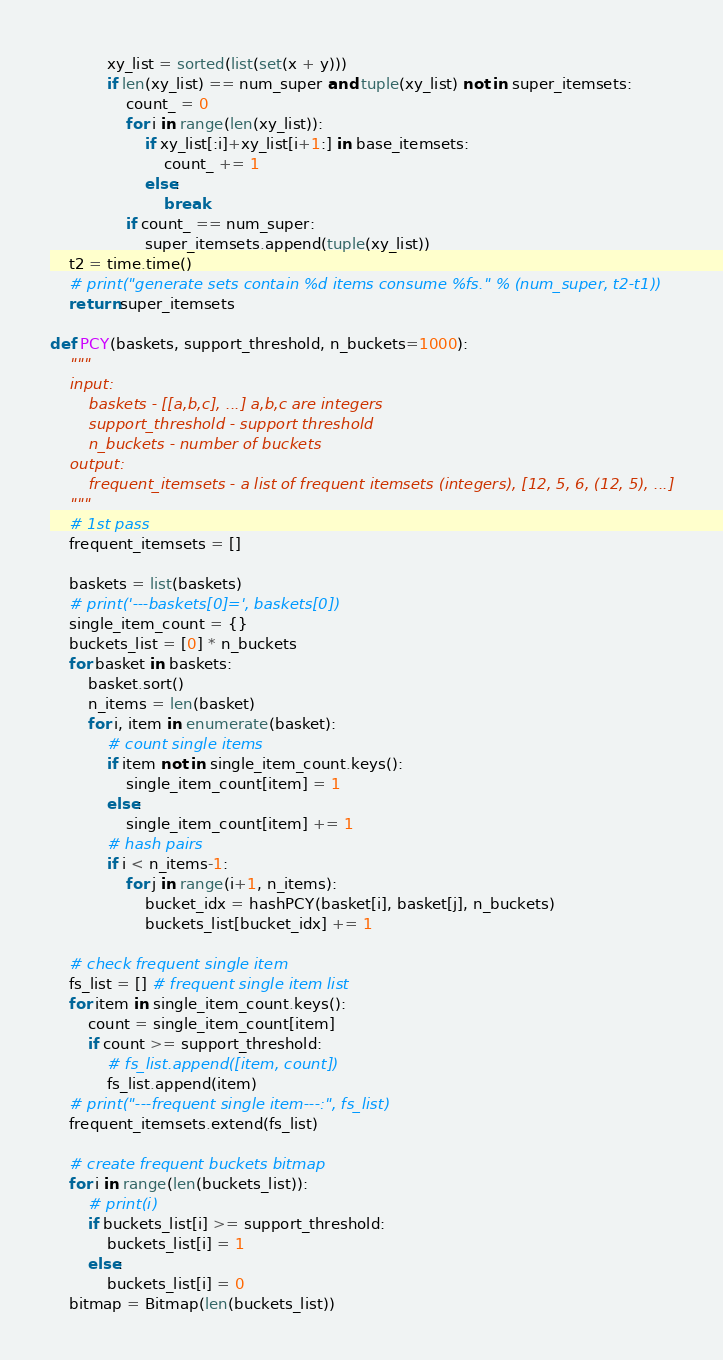<code> <loc_0><loc_0><loc_500><loc_500><_Python_>            xy_list = sorted(list(set(x + y)))
            if len(xy_list) == num_super and tuple(xy_list) not in super_itemsets:
                count_ = 0
                for i in range(len(xy_list)):
                    if xy_list[:i]+xy_list[i+1:] in base_itemsets:
                        count_ += 1
                    else:
                        break
                if count_ == num_super:
                    super_itemsets.append(tuple(xy_list))
    t2 = time.time()
    # print("generate sets contain %d items consume %fs." % (num_super, t2-t1))
    return super_itemsets

def PCY(baskets, support_threshold, n_buckets=1000):
    """
    input:
        baskets - [[a,b,c], ...] a,b,c are integers
        support_threshold - support threshold
        n_buckets - number of buckets
    output:
        frequent_itemsets - a list of frequent itemsets (integers), [12, 5, 6, (12, 5), ...]
    """
    # 1st pass
    frequent_itemsets = []

    baskets = list(baskets)
    # print('---baskets[0]=', baskets[0])
    single_item_count = {}
    buckets_list = [0] * n_buckets
    for basket in baskets:
        basket.sort()
        n_items = len(basket)
        for i, item in enumerate(basket):
            # count single items
            if item not in single_item_count.keys():
                single_item_count[item] = 1
            else:
                single_item_count[item] += 1
            # hash pairs
            if i < n_items-1:
                for j in range(i+1, n_items):
                    bucket_idx = hashPCY(basket[i], basket[j], n_buckets)
                    buckets_list[bucket_idx] += 1

    # check frequent single item
    fs_list = [] # frequent single item list
    for item in single_item_count.keys():
        count = single_item_count[item]
        if count >= support_threshold:
            # fs_list.append([item, count])
            fs_list.append(item)
    # print("---frequent single item---:", fs_list)
    frequent_itemsets.extend(fs_list)

    # create frequent buckets bitmap
    for i in range(len(buckets_list)):
        # print(i)
        if buckets_list[i] >= support_threshold:
            buckets_list[i] = 1
        else:
            buckets_list[i] = 0
    bitmap = Bitmap(len(buckets_list))</code> 